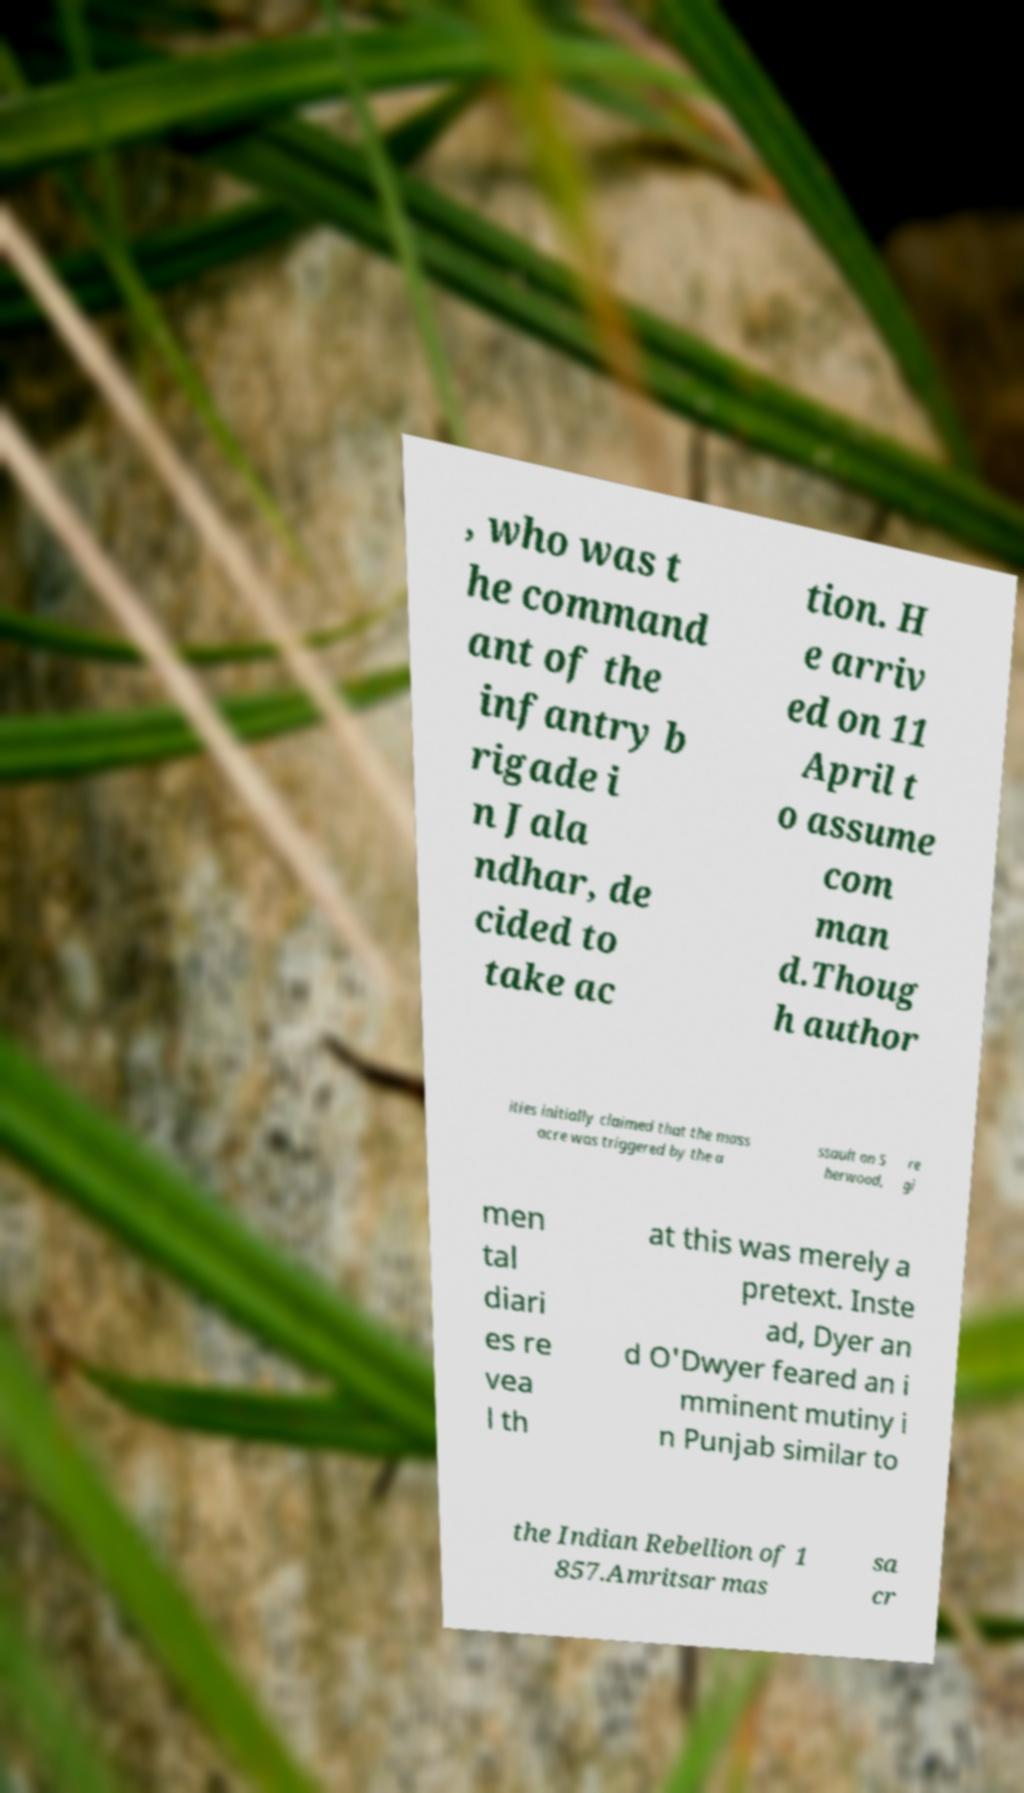Please identify and transcribe the text found in this image. , who was t he command ant of the infantry b rigade i n Jala ndhar, de cided to take ac tion. H e arriv ed on 11 April t o assume com man d.Thoug h author ities initially claimed that the mass acre was triggered by the a ssault on S herwood, re gi men tal diari es re vea l th at this was merely a pretext. Inste ad, Dyer an d O'Dwyer feared an i mminent mutiny i n Punjab similar to the Indian Rebellion of 1 857.Amritsar mas sa cr 